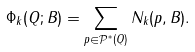Convert formula to latex. <formula><loc_0><loc_0><loc_500><loc_500>\Phi _ { k } ( Q ; B ) = \sum _ { p \in \mathcal { P } ^ { * } ( Q ) } N _ { k } ( p , B ) .</formula> 